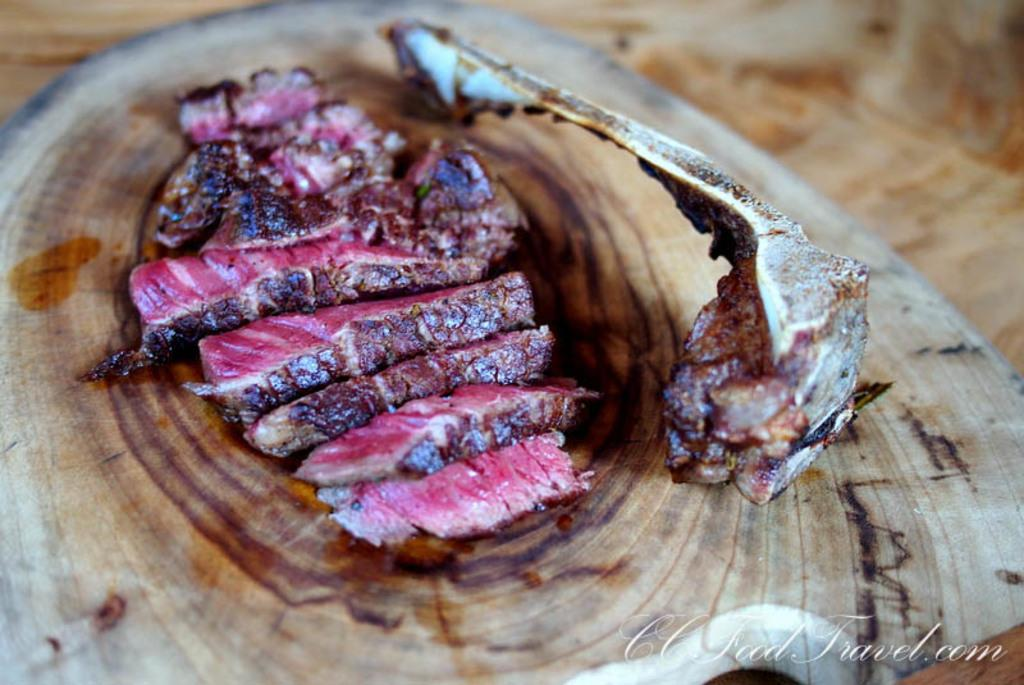What is on the wooden plate in the image? There are meat pieces and a bone on the wooden plate in the image. Can you describe the plate itself? The plate is made of wood. Is there any visible text or mark in the image? Yes, there is a watermark in the bottom right corner of the image. How would you describe the background of the image? The background of the image is blurred. How many cows can be seen grazing in the background of the image? There are no cows visible in the image; the background is blurred. What type of cart is used to transport the meat in the image? There is no cart present in the image; the meat is on a wooden plate. 